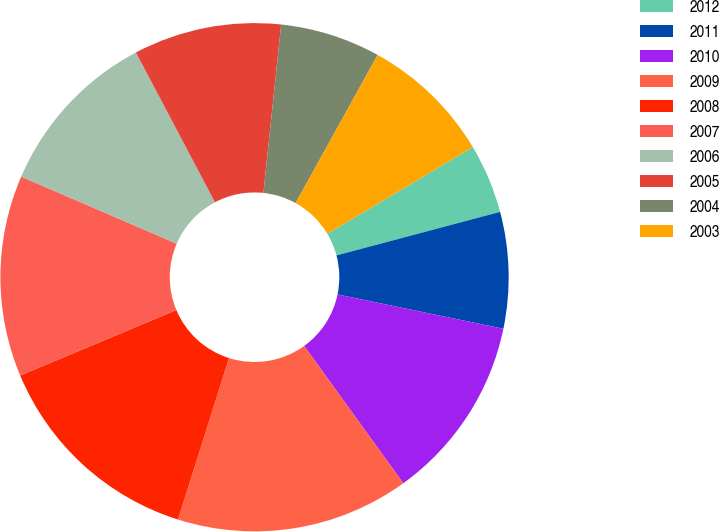Convert chart. <chart><loc_0><loc_0><loc_500><loc_500><pie_chart><fcel>2012<fcel>2011<fcel>2010<fcel>2009<fcel>2008<fcel>2007<fcel>2006<fcel>2005<fcel>2004<fcel>2003<nl><fcel>4.42%<fcel>7.39%<fcel>11.8%<fcel>14.82%<fcel>13.81%<fcel>12.8%<fcel>10.79%<fcel>9.4%<fcel>6.38%<fcel>8.39%<nl></chart> 